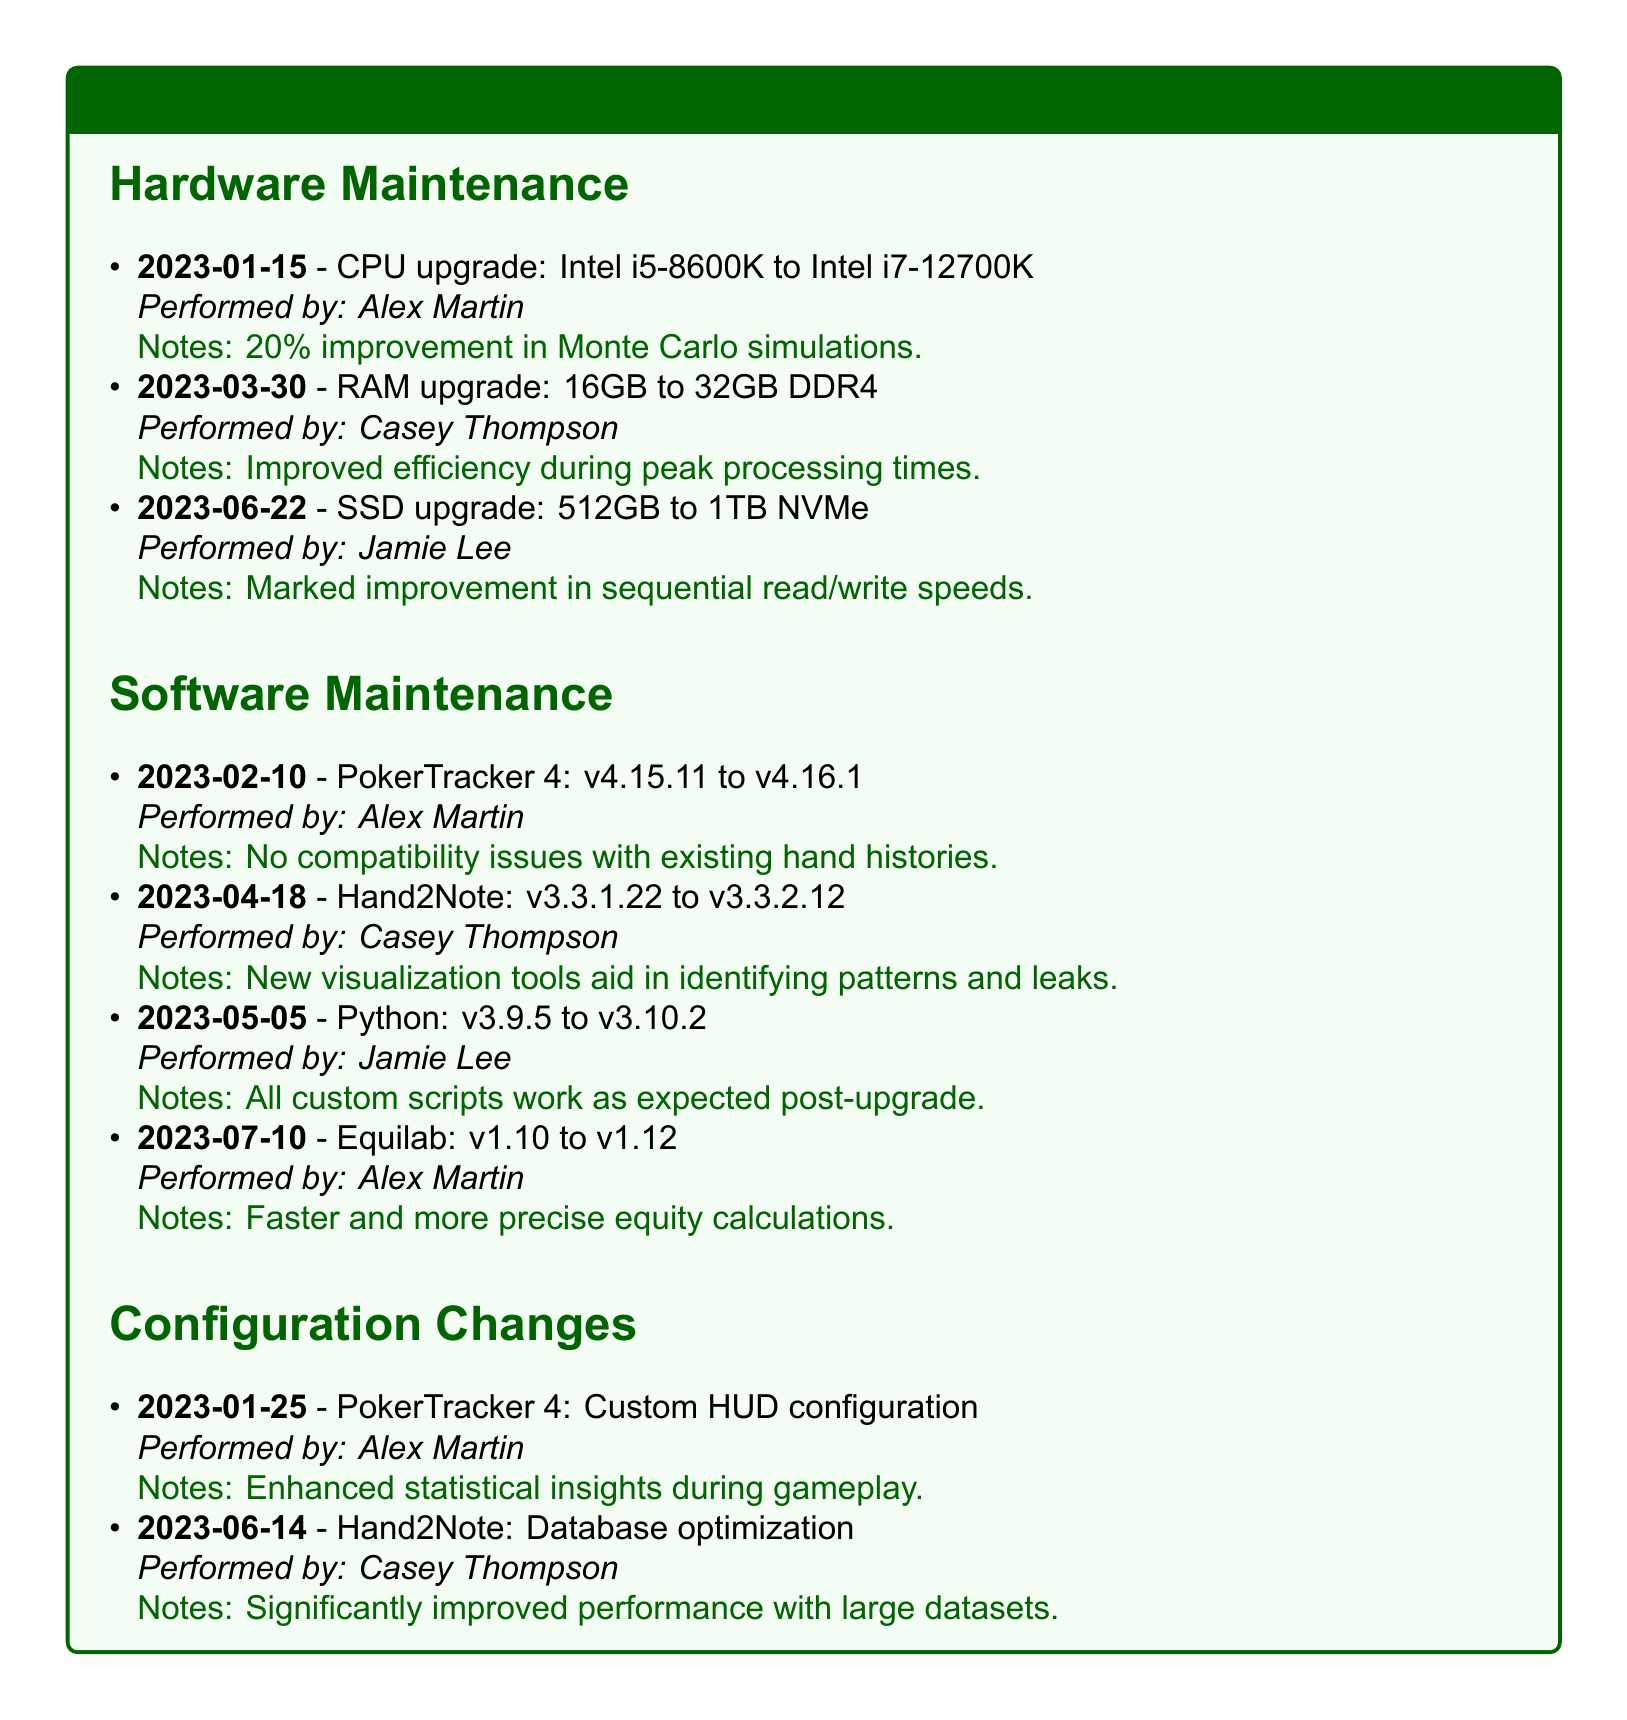What date was the CPU upgraded? The document states the CPU was upgraded on January 15, 2023.
Answer: January 15, 2023 What increase in RAM was made? The log mentions the RAM was upgraded from 16GB to 32GB.
Answer: 16GB to 32GB Who performed the SSD upgrade? The entry for the SSD upgrade indicates it was performed by Jamie Lee.
Answer: Jamie Lee What version was PokerTracker 4 upgraded to? The log specifies that PokerTracker 4 was upgraded to version 4.16.1.
Answer: v4.16.1 What was the main improvement noted from the RAM upgrade? The document states that efficiency during peak processing times improved after the RAM upgrade.
Answer: Improved efficiency during peak processing times Which software got new visualization tools? Hand2Note received new visualization tools, as noted in the software maintenance section.
Answer: Hand2Note What was optimized in Hand2Note on June 14? The log records that database optimization was performed for Hand2Note on June 14.
Answer: Database optimization How much was the SSD storage increased by after the upgrade? The document mentions an increase from 512GB to 1TB, which is a total increase of 488GB.
Answer: 488GB What was the purpose of the custom HUD configuration in PokerTracker 4? The document indicates that the custom HUD configuration enhanced statistical insights during gameplay.
Answer: Enhanced statistical insights during gameplay 